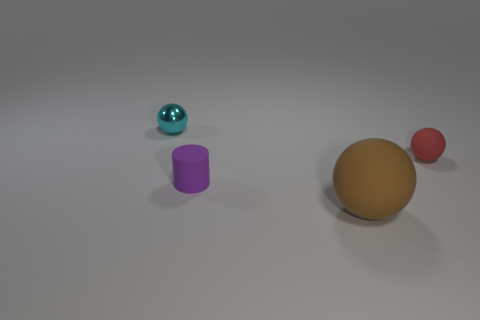Subtract all tiny balls. How many balls are left? 1 Add 2 purple cylinders. How many objects exist? 6 Subtract 1 spheres. How many spheres are left? 2 Subtract all cylinders. How many objects are left? 3 Subtract all purple balls. Subtract all yellow cubes. How many balls are left? 3 Subtract all tiny cyan metallic things. Subtract all yellow matte blocks. How many objects are left? 3 Add 1 metallic balls. How many metallic balls are left? 2 Add 3 large brown rubber spheres. How many large brown rubber spheres exist? 4 Subtract 0 blue blocks. How many objects are left? 4 